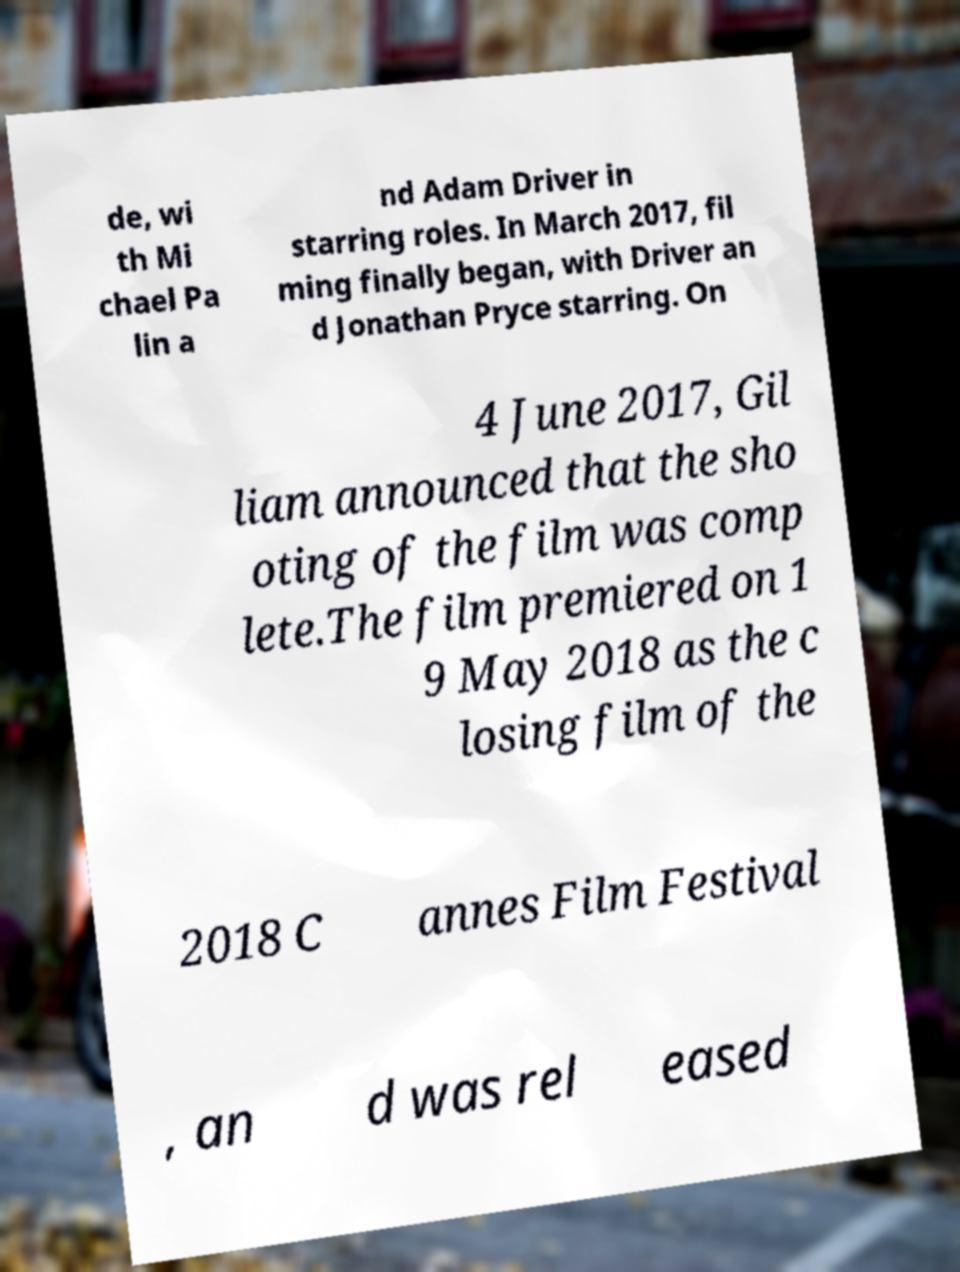Can you accurately transcribe the text from the provided image for me? de, wi th Mi chael Pa lin a nd Adam Driver in starring roles. In March 2017, fil ming finally began, with Driver an d Jonathan Pryce starring. On 4 June 2017, Gil liam announced that the sho oting of the film was comp lete.The film premiered on 1 9 May 2018 as the c losing film of the 2018 C annes Film Festival , an d was rel eased 